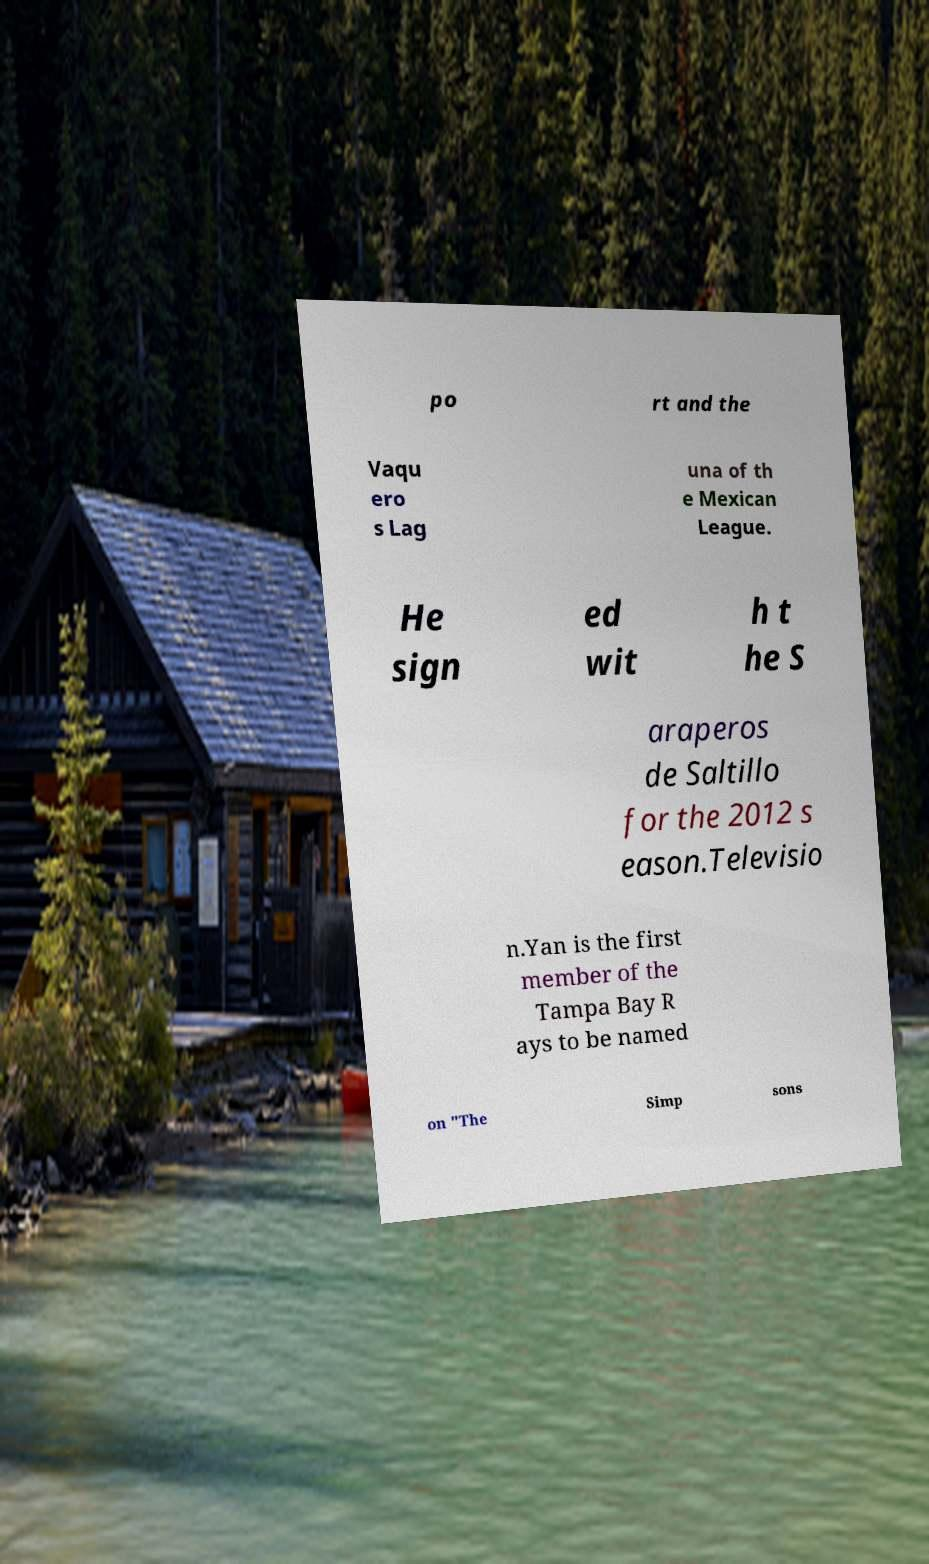There's text embedded in this image that I need extracted. Can you transcribe it verbatim? po rt and the Vaqu ero s Lag una of th e Mexican League. He sign ed wit h t he S araperos de Saltillo for the 2012 s eason.Televisio n.Yan is the first member of the Tampa Bay R ays to be named on "The Simp sons 